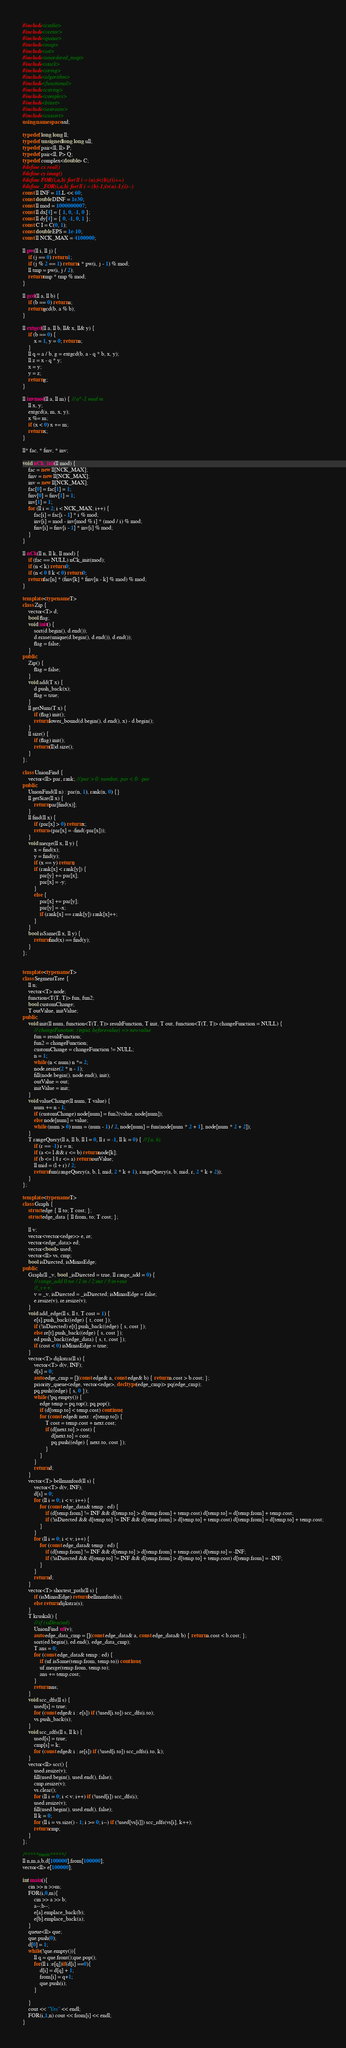<code> <loc_0><loc_0><loc_500><loc_500><_C++_>#include<cstdio>
#include<vector>
#include<queue>
#include<map>
#include<set>
#include<unordered_map>
#include<stack>
#include<string>
#include<algorithm>
#include<functional>
#include<cstring>
#include<complex>
#include<bitset>
#include<iostream>
#include<cassert>
using namespace std;

typedef long long ll;
typedef unsigned long long ull;
typedef pair<ll, ll> P;
typedef pair<ll, P> Q;
typedef complex<double> C;
#define cx real()
#define cy imag()
#define FOR(i,a,b) for(ll i = (a);i<(b);(i)++)
#define _FOR(i,a,b) for(ll i = (b)-1;i>(a)-1;(i)--)
const ll INF = 1LL << 60;
const double DINF = 1e30;
const ll mod = 1000000007;
const ll dx[4] = { 1, 0, -1, 0 };
const ll dy[4] = { 0, -1, 0, 1 };
const C I = C(0, 1);
const double EPS = 1e-10;
const ll NCK_MAX = 4100000;

ll pw(ll i, ll j) {
	if (j == 0) return 1;
	if (j % 2 == 1) return i * pw(i, j - 1) % mod;
	ll tmp = pw(i, j / 2);
	return tmp * tmp % mod;
}

ll gcd(ll a, ll b) {
	if (b == 0) return a;
	return gcd(b, a % b);
}

ll extgcd(ll a, ll b, ll& x, ll& y) {
	if (b == 0) {
		x = 1, y = 0; return a;
	}
	ll q = a / b, g = extgcd(b, a - q * b, x, y);
	ll z = x - q * y;
	x = y;
	y = z;
	return g;
}

ll invmod(ll a, ll m) { // a^-1 mod m
	ll x, y;
	extgcd(a, m, x, y);
	x %= m;
	if (x < 0) x += m;
	return x;
}

ll* fac, * finv, * inv;

void nCk_init(ll mod) {
	fac = new ll[NCK_MAX];
	finv = new ll[NCK_MAX];
	inv = new ll[NCK_MAX];
	fac[0] = fac[1] = 1;
	finv[0] = finv[1] = 1;
	inv[1] = 1;
	for (ll i = 2; i < NCK_MAX; i++) {
		fac[i] = fac[i - 1] * i % mod;
		inv[i] = mod - inv[mod % i] * (mod / i) % mod;
		finv[i] = finv[i - 1] * inv[i] % mod;
	}
}

ll nCk(ll n, ll k, ll mod) {
	if (fac == NULL) nCk_init(mod);
	if (n < k) return 0;
	if (n < 0 || k < 0) return 0;
	return fac[n] * (finv[k] * finv[n - k] % mod) % mod;
}

template <typename T>
class Zip {
	vector<T> d;
	bool flag;
	void init() {
		sort(d.begin(), d.end());
		d.erase(unique(d.begin(), d.end()), d.end());
		flag = false;
	}
public:
	Zip() {
		flag = false;
	}
	void add(T x) {
		d.push_back(x);
		flag = true;
	}
	ll getNum(T x) {
		if (flag) init();
		return lower_bound(d.begin(), d.end(), x) - d.begin();
	}
	ll size() {
		if (flag) init();
		return (ll)d.size();
	}
};

class UnionFind {
	vector<ll> par, rank; // par > 0: number, par < 0: -par
public:
	UnionFind(ll n) : par(n, 1), rank(n, 0) {}
	ll getSize(ll x) {
		return par[find(x)];
	}
	ll find(ll x) {
		if (par[x] > 0) return x;
		return -(par[x] = -find(-par[x]));
	}
	void merge(ll x, ll y) {
		x = find(x);
		y = find(y);
		if (x == y) return;
		if (rank[x] < rank[y]) {
			par[y] += par[x];
			par[x] = -y;
		}
		else {
			par[x] += par[y];
			par[y] = -x;
			if (rank[x] == rank[y]) rank[x]++;
		}
	}
	bool isSame(ll x, ll y) {
		return find(x) == find(y);
	}
};


template <typename T>
class SegmentTree {
	ll n;
	vector<T> node;
	function<T(T, T)> fun, fun2;
	bool customChange;
	T outValue, initValue;
public:
	void init(ll num, function<T(T, T)> resultFunction, T init, T out, function<T(T, T)> changeFunction = NULL) {
		// changeFunction: (input, beforevalue) => newvalue
		fun = resultFunction;
		fun2 = changeFunction;
		customChange = changeFunction != NULL;
		n = 1;
		while (n < num) n *= 2;
		node.resize(2 * n - 1);
		fill(node.begin(), node.end(), init);
		outValue = out;
		initValue = init;
	}
	void valueChange(ll num, T value) {
		num += n - 1;
		if (customChange) node[num] = fun2(value, node[num]);
		else node[num] = value;
		while (num > 0) num = (num - 1) / 2, node[num] = fun(node[num * 2 + 1], node[num * 2 + 2]);
	}
	T rangeQuery(ll a, ll b, ll l = 0, ll r = -1, ll k = 0) { // [a, b)
		if (r == -1) r = n;
		if (a <= l && r <= b) return node[k];
		if (b <= l || r <= a) return outValue;
		ll mid = (l + r) / 2;
		return fun(rangeQuery(a, b, l, mid, 2 * k + 1), rangeQuery(a, b, mid, r, 2 * k + 2));
	}
};

template <typename T>
class Graph {
	struct edge { ll to; T cost; };
	struct edge_data { ll from, to; T cost; };

	ll v;
	vector<vector<edge>> e, re;
	vector<edge_data> ed;
	vector<bool> used;
	vector<ll> vs, cmp;
	bool isDirected, isMinasEdge;
public:
	Graph(ll _v, bool _isDirected = true, ll range_add = 0) {
		// range_add 0:no / 1:in / 2:out / 3:in+out
		//_v++;
		v = _v, isDirected = _isDirected; isMinasEdge = false;
		e.resize(v), re.resize(v);
	}
	void add_edge(ll s, ll t, T cost = 1) {
		e[s].push_back((edge) { t, cost });
		if (!isDirected) e[t].push_back((edge) { s, cost });
		else re[t].push_back((edge) { s, cost });
		ed.push_back((edge_data) { s, t, cost });
		if (cost < 0) isMinasEdge = true;
	}
	vector<T> dijkstra(ll s) {
		vector<T> d(v, INF);
		d[s] = 0;
		auto edge_cmp = [](const edge& a, const edge& b) { return a.cost > b.cost; };
		priority_queue<edge, vector<edge>, decltype(edge_cmp)> pq(edge_cmp);
		pq.push((edge) { s, 0 });
		while (!pq.empty()) {
			edge temp = pq.top(); pq.pop();
			if (d[temp.to] < temp.cost) continue;
			for (const edge& next : e[temp.to]) {
				T cost = temp.cost + next.cost;
				if (d[next.to] > cost) {
					d[next.to] = cost;
					pq.push((edge) { next.to, cost });
				}
			}
		}
		return d;
	}
	vector<T> bellmanford(ll s) {
		vector<T> d(v, INF);
		d[s] = 0;
		for (ll i = 0; i < v; i++) {
			for (const edge_data& temp : ed) {
				if (d[temp.from] != INF && d[temp.to] > d[temp.from] + temp.cost) d[temp.to] = d[temp.from] + temp.cost;
				if (!isDirected && d[temp.to] != INF && d[temp.from] > d[temp.to] + temp.cost) d[temp.from] = d[temp.to] + temp.cost;
			}
		}
		for (ll i = 0; i < v; i++) {
			for (const edge_data& temp : ed) {
				if (d[temp.from] != INF && d[temp.to] > d[temp.from] + temp.cost) d[temp.to] = -INF;
				if (!isDirected && d[temp.to] != INF && d[temp.from] > d[temp.to] + temp.cost) d[temp.from] = -INF;
			}
		}
		return d;
	}
	vector<T> shortest_path(ll s) {
		if (isMinasEdge) return bellmanford(s);
		else return dijkstra(s);
	}
	T kruskal() {
		// if (isDirected)
		UnionFind uf(v);
		auto edge_data_cmp = [](const edge_data& a, const edge_data& b) { return a.cost < b.cost; };
		sort(ed.begin(), ed.end(), edge_data_cmp);
		T ans = 0;
		for (const edge_data& temp : ed) {
			if (uf.isSame(temp.from, temp.to)) continue;
			uf.merge(temp.from, temp.to);
			ans += temp.cost;
		}
		return ans;
	}
	void scc_dfs(ll s) {
		used[s] = true;
		for (const edge& i : e[s]) if (!used[i.to]) scc_dfs(i.to);
		vs.push_back(s);
	}
	void scc_rdfs(ll s, ll k) {
		used[s] = true;
		cmp[s] = k;
		for (const edge& i : re[s]) if (!used[i.to]) scc_rdfs(i.to, k);
	}
	vector<ll> scc() {
		used.resize(v);
		fill(used.begin(), used.end(), false);
		cmp.resize(v);
		vs.clear();
		for (ll i = 0; i < v; i++) if (!used[i]) scc_dfs(i);
		used.resize(v);
		fill(used.begin(), used.end(), false);
		ll k = 0;
		for (ll i = vs.size() - 1; i >= 0; i--) if (!used[vs[i]]) scc_rdfs(vs[i], k++);
		return cmp;
	}
};

/*****main*****/
ll n,m,a,b,d[100000],from[100000];
vector<ll> e[100000];

int main(){
	cin >> n >>m;
	FOR(i,0,m){
		cin >> a >> b;
		a--;b--;
		e[a].emplace_back(b);
		e[b].emplace_back(a);
	}
	queue<ll> que;
	que.push(0);
	d[0] = 1;
	while(!que.empty()){
		ll q = que.front();que.pop();
		for(ll i :e[q])if(d[i] ==0){
			d[i] = d[q] + 1;
			from[i] = q+1;
			que.push(i);
		}

	}
	cout << "Yes" << endl;
	FOR(i,1,n) cout << from[i] << endl;
}
</code> 